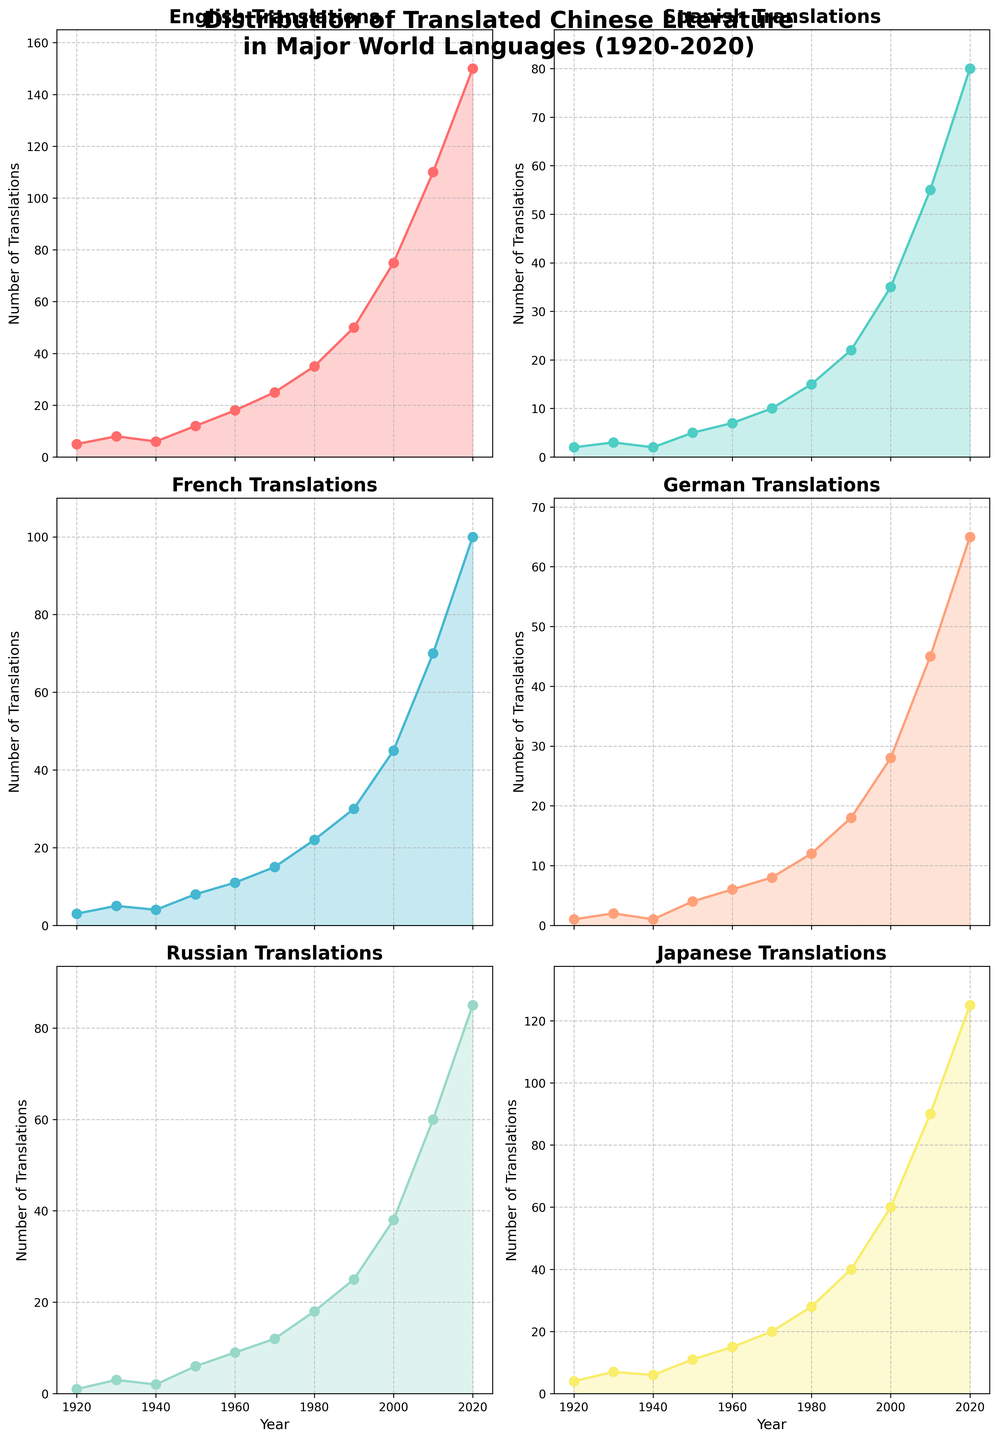What language saw the highest number of translations in 2020? By observing the plots, it's evident that the highest peak in 2020 across the six languages appears in the English subplot.
Answer: English Which language had a comparatively steady increase in the number of translations throughout the century? By analyzing the trends in the plots, French shows a steady and consistent increase without notable fluctuations compared to the other languages.
Answer: French By how much did Japanese translations increase from 1980 to 2000? Looking at the Japanese subplot, the number of translations in 1980 is 28 and in 2000 it is 60. The difference between these two values is 60 - 28 = 32.
Answer: 32 Compare the number of German and Spanish translations in the 1950s. Which language had more translations and by what amount? In the 1950s, the number of translations for German is 4 and for Spanish is 5. The difference is 5 - 4 = 1, indicating Spanish had 1 more translation than German.
Answer: Spanish, by 1 Which language showed the largest increase in the number of translations between 2010 and 2020? By examining the changes between 2010 and 2020 for all languages, English shows the largest increase from 110 to 150. The increase is 150 - 110 = 40.
Answer: English In the 1970s, which language had the closest number of translations to French? In the 1970s, French had 15 translations. By comparing this to the other languages, German had 8, Russian had 12, Spanish had 10, English had 25, and Japanese had 20. The closest number to 15 is Spanish with 10.
Answer: Spanish How did the number of Russian translations in 1960 compare to those in 1920? In 1960, Russian translations are at 9, while in 1920, they are at 1. The increase is calculated as 9 - 1 = 8 times more in 1960 than in 1920.
Answer: 8 times more What is the trend in Spanish translations from 1980 to 2020? By reviewing the Spanish subplot, the number of translations shows an increasing trend from 15 in 1980 to 80 in 2020. This is a steady upward trend over the four decades.
Answer: Increasing Compare the peak number of translations in the 1940s for Russian and German. Which language had more translations and by what amount? In the 1940s, Russian had 2 translations and German had 1. The difference is 2 - 1 = 1 in favor of Russian.
Answer: Russian, by 1 What is the visual color associated with the plot for French translations? By observing the colors of the subplots, the color used for French translations is a shade of blue.
Answer: Blue 